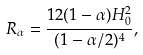<formula> <loc_0><loc_0><loc_500><loc_500>R _ { \alpha } = \frac { 1 2 ( 1 - \alpha ) H _ { 0 } ^ { 2 } } { ( 1 - \alpha / 2 ) ^ { 4 } } ,</formula> 